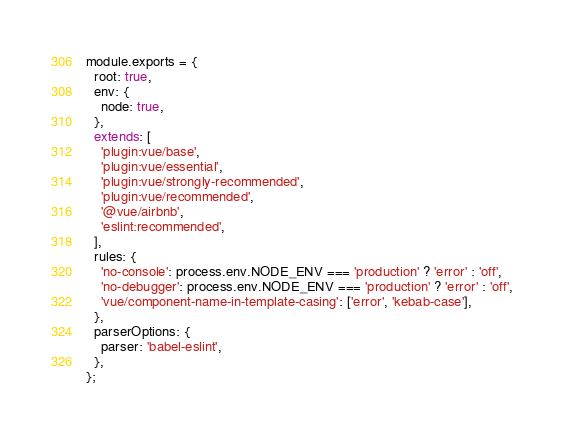Convert code to text. <code><loc_0><loc_0><loc_500><loc_500><_JavaScript_>module.exports = {
  root: true,
  env: {
    node: true,
  },
  extends: [
    'plugin:vue/base',
    'plugin:vue/essential',
    'plugin:vue/strongly-recommended',
    'plugin:vue/recommended',
    '@vue/airbnb',
    'eslint:recommended',
  ],
  rules: {
    'no-console': process.env.NODE_ENV === 'production' ? 'error' : 'off',
    'no-debugger': process.env.NODE_ENV === 'production' ? 'error' : 'off',
    'vue/component-name-in-template-casing': ['error', 'kebab-case'],
  },
  parserOptions: {
    parser: 'babel-eslint',
  },
};
</code> 